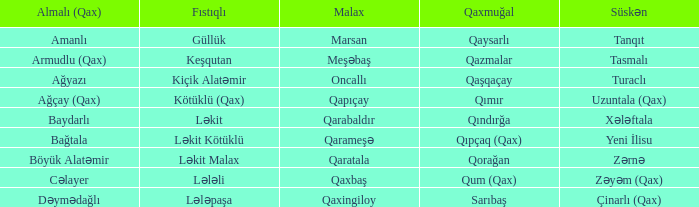What is the qaxmuğal village with a fistiqli village exploration? Qazmalar. 